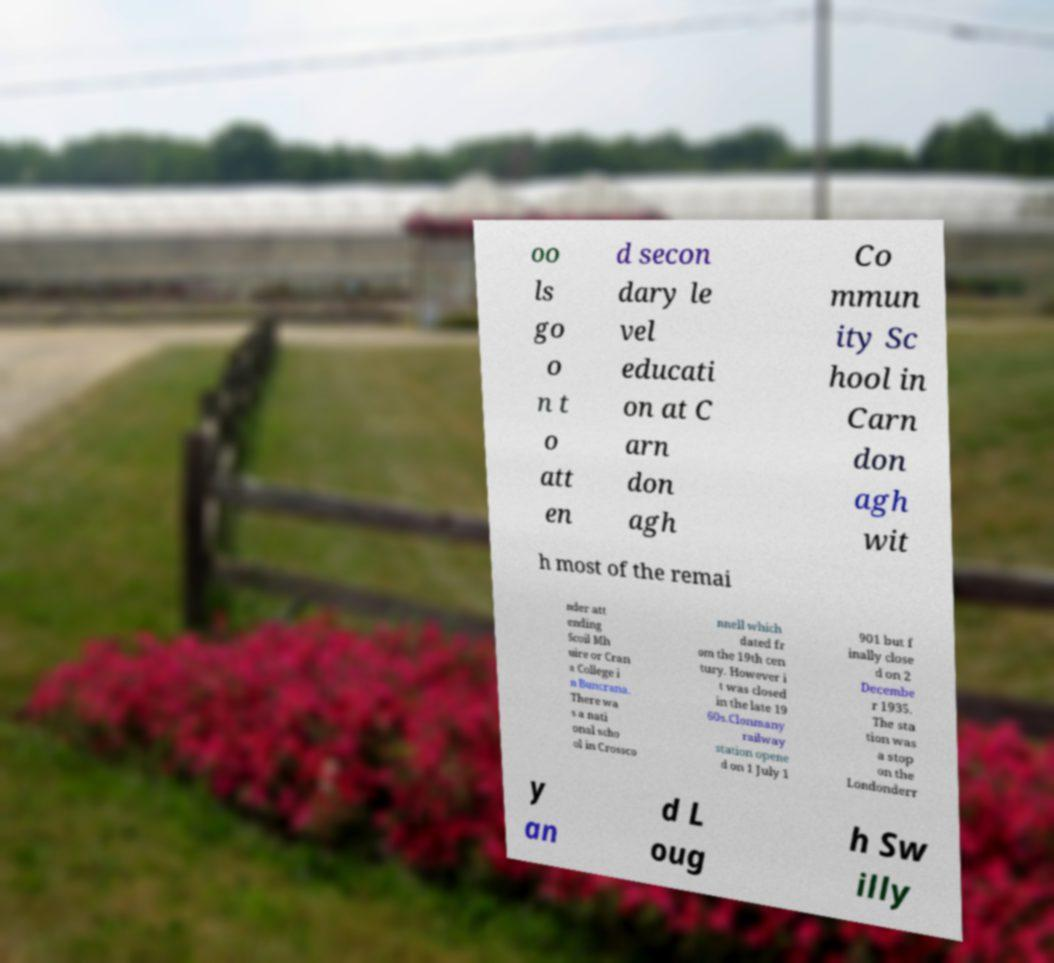Could you extract and type out the text from this image? oo ls go o n t o att en d secon dary le vel educati on at C arn don agh Co mmun ity Sc hool in Carn don agh wit h most of the remai nder att ending Scoil Mh uire or Cran a College i n Buncrana. There wa s a nati onal scho ol in Crossco nnell which dated fr om the 19th cen tury. However i t was closed in the late 19 60s.Clonmany railway station opene d on 1 July 1 901 but f inally close d on 2 Decembe r 1935. The sta tion was a stop on the Londonderr y an d L oug h Sw illy 